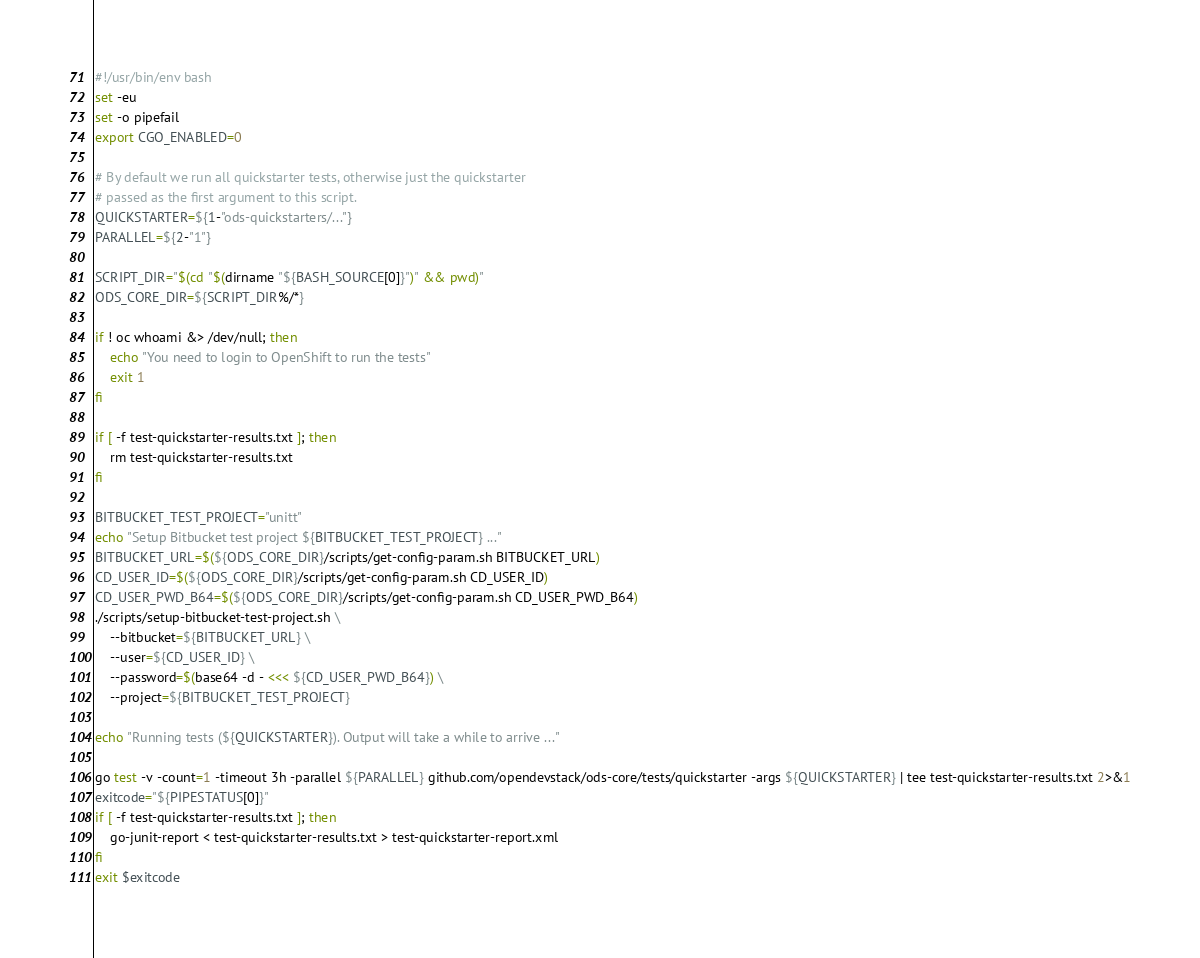Convert code to text. <code><loc_0><loc_0><loc_500><loc_500><_Bash_>#!/usr/bin/env bash
set -eu
set -o pipefail
export CGO_ENABLED=0

# By default we run all quickstarter tests, otherwise just the quickstarter
# passed as the first argument to this script.
QUICKSTARTER=${1-"ods-quickstarters/..."}
PARALLEL=${2-"1"}

SCRIPT_DIR="$(cd "$(dirname "${BASH_SOURCE[0]}")" && pwd)"
ODS_CORE_DIR=${SCRIPT_DIR%/*}

if ! oc whoami &> /dev/null; then
    echo "You need to login to OpenShift to run the tests"
    exit 1
fi

if [ -f test-quickstarter-results.txt ]; then
    rm test-quickstarter-results.txt
fi

BITBUCKET_TEST_PROJECT="unitt"
echo "Setup Bitbucket test project ${BITBUCKET_TEST_PROJECT} ..."
BITBUCKET_URL=$(${ODS_CORE_DIR}/scripts/get-config-param.sh BITBUCKET_URL)
CD_USER_ID=$(${ODS_CORE_DIR}/scripts/get-config-param.sh CD_USER_ID)
CD_USER_PWD_B64=$(${ODS_CORE_DIR}/scripts/get-config-param.sh CD_USER_PWD_B64)
./scripts/setup-bitbucket-test-project.sh \
    --bitbucket=${BITBUCKET_URL} \
    --user=${CD_USER_ID} \
    --password=$(base64 -d - <<< ${CD_USER_PWD_B64}) \
    --project=${BITBUCKET_TEST_PROJECT}

echo "Running tests (${QUICKSTARTER}). Output will take a while to arrive ..."

go test -v -count=1 -timeout 3h -parallel ${PARALLEL} github.com/opendevstack/ods-core/tests/quickstarter -args ${QUICKSTARTER} | tee test-quickstarter-results.txt 2>&1
exitcode="${PIPESTATUS[0]}"
if [ -f test-quickstarter-results.txt ]; then
    go-junit-report < test-quickstarter-results.txt > test-quickstarter-report.xml
fi
exit $exitcode
</code> 